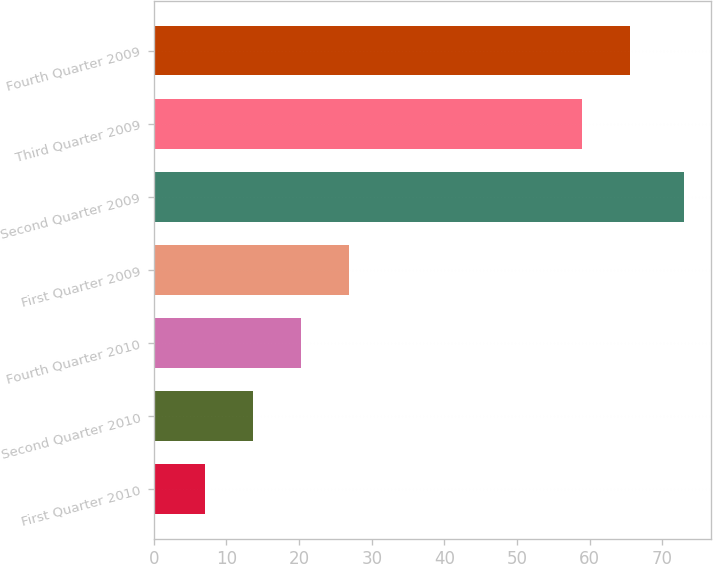Convert chart. <chart><loc_0><loc_0><loc_500><loc_500><bar_chart><fcel>First Quarter 2010<fcel>Second Quarter 2010<fcel>Fourth Quarter 2010<fcel>First Quarter 2009<fcel>Second Quarter 2009<fcel>Third Quarter 2009<fcel>Fourth Quarter 2009<nl><fcel>7<fcel>13.6<fcel>20.2<fcel>26.8<fcel>73<fcel>59<fcel>65.6<nl></chart> 